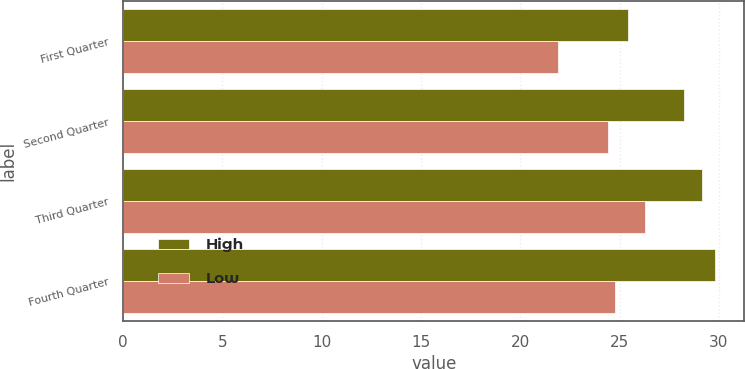Convert chart. <chart><loc_0><loc_0><loc_500><loc_500><stacked_bar_chart><ecel><fcel>First Quarter<fcel>Second Quarter<fcel>Third Quarter<fcel>Fourth Quarter<nl><fcel>High<fcel>25.41<fcel>28.25<fcel>29.17<fcel>29.8<nl><fcel>Low<fcel>21.88<fcel>24.42<fcel>26.26<fcel>24.79<nl></chart> 